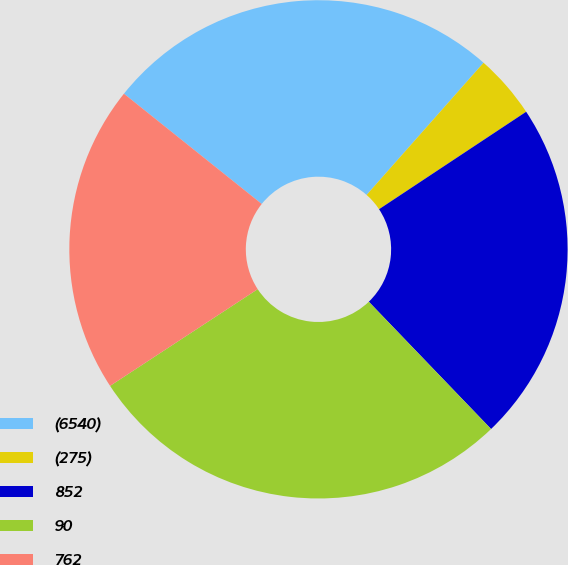Convert chart. <chart><loc_0><loc_0><loc_500><loc_500><pie_chart><fcel>(6540)<fcel>(275)<fcel>852<fcel>90<fcel>762<nl><fcel>25.79%<fcel>4.16%<fcel>22.13%<fcel>27.95%<fcel>19.97%<nl></chart> 